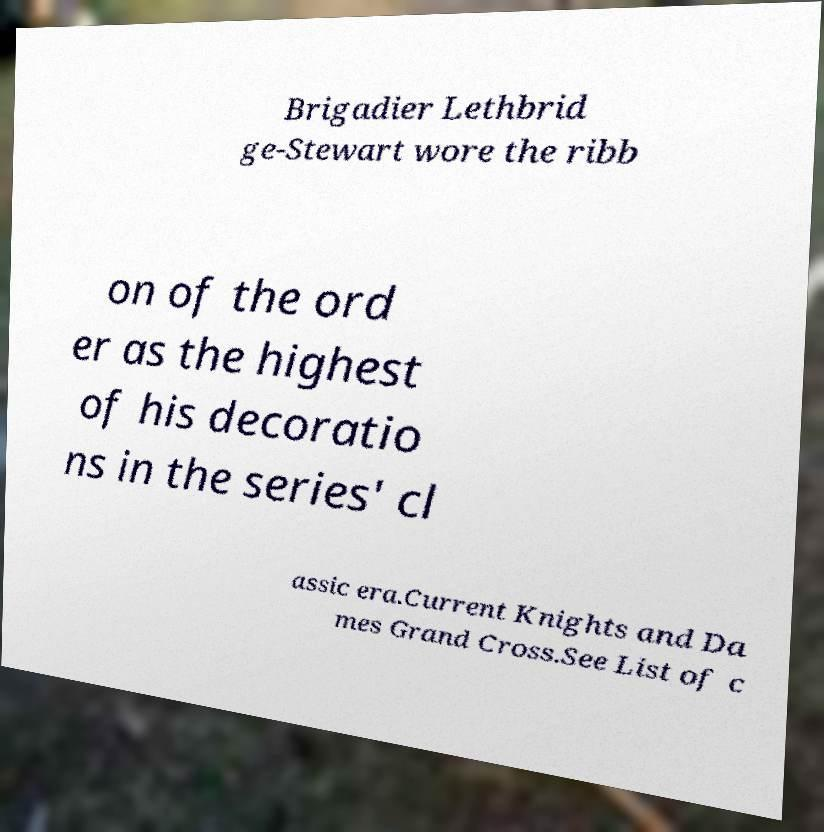Could you extract and type out the text from this image? Brigadier Lethbrid ge-Stewart wore the ribb on of the ord er as the highest of his decoratio ns in the series' cl assic era.Current Knights and Da mes Grand Cross.See List of c 